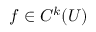Convert formula to latex. <formula><loc_0><loc_0><loc_500><loc_500>f \in C ^ { k } ( U )</formula> 